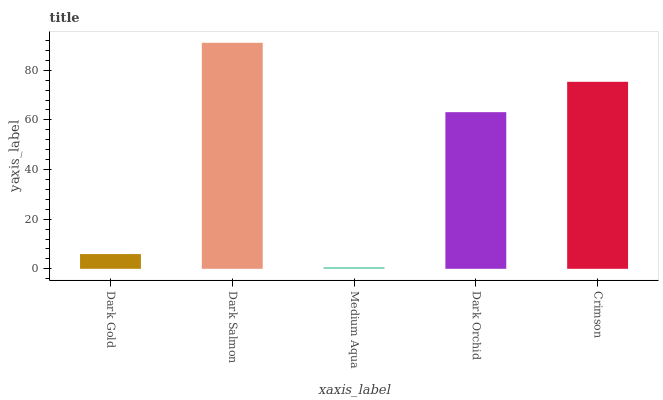Is Medium Aqua the minimum?
Answer yes or no. Yes. Is Dark Salmon the maximum?
Answer yes or no. Yes. Is Dark Salmon the minimum?
Answer yes or no. No. Is Medium Aqua the maximum?
Answer yes or no. No. Is Dark Salmon greater than Medium Aqua?
Answer yes or no. Yes. Is Medium Aqua less than Dark Salmon?
Answer yes or no. Yes. Is Medium Aqua greater than Dark Salmon?
Answer yes or no. No. Is Dark Salmon less than Medium Aqua?
Answer yes or no. No. Is Dark Orchid the high median?
Answer yes or no. Yes. Is Dark Orchid the low median?
Answer yes or no. Yes. Is Dark Salmon the high median?
Answer yes or no. No. Is Dark Salmon the low median?
Answer yes or no. No. 